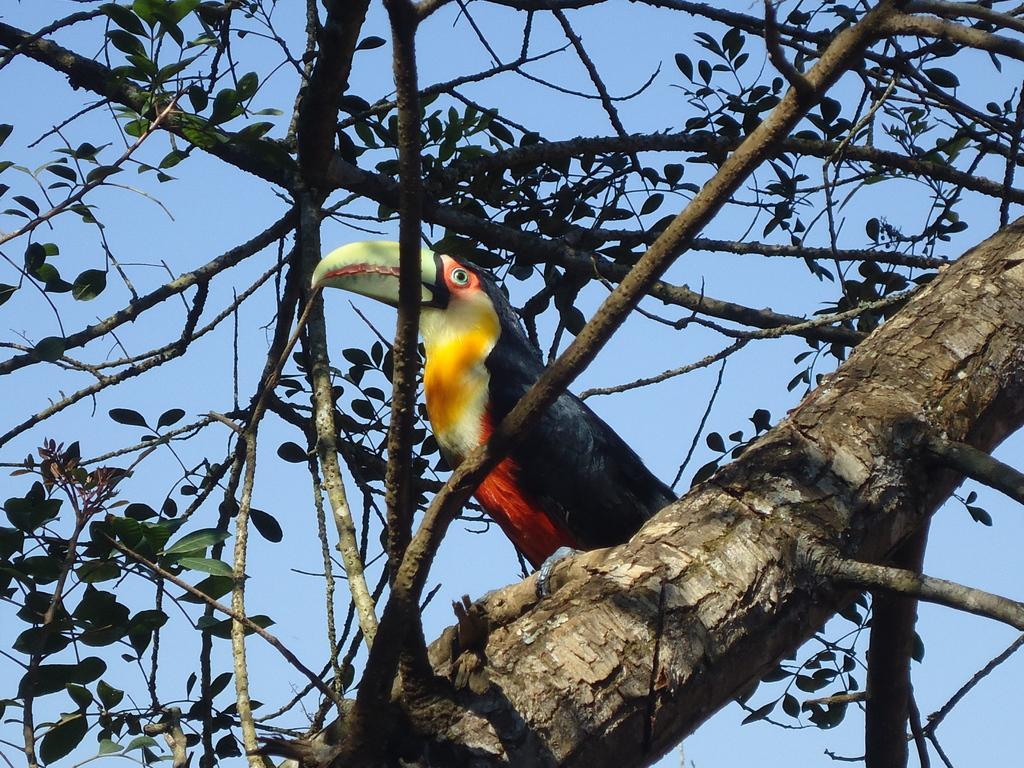In one or two sentences, can you explain what this image depicts? In the foreground of this image, there is a woodpecker on a tree. In the background, there is the sky. 